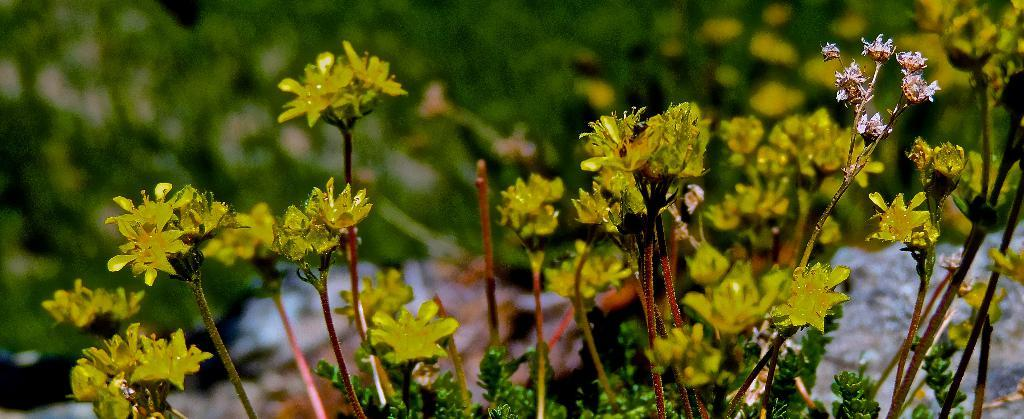What type of living organisms are in the image? The image contains plants. What color are the flowers on the plants? The flowers on the plants are yellow. What is the opinion of the partner in the image about the argument presented? There is no reference to an argument, opinion, or partner in the image, as it features plants with yellow flowers. 